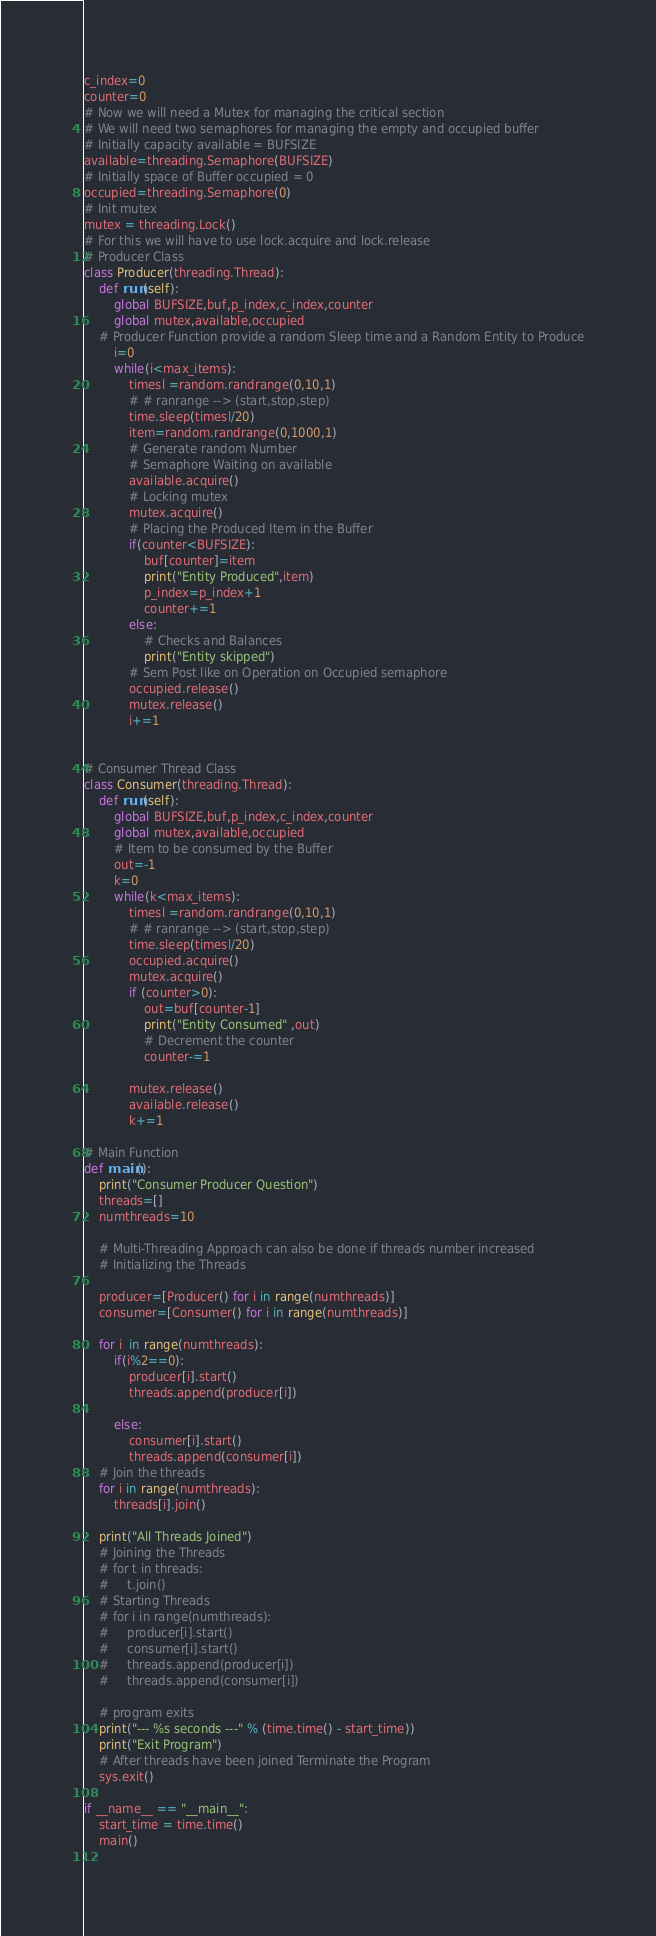<code> <loc_0><loc_0><loc_500><loc_500><_Python_>c_index=0
counter=0
# Now we will need a Mutex for managing the critical section
# We will need two semaphores for managing the empty and occupied buffer
# Initially capacity available = BUFSIZE
available=threading.Semaphore(BUFSIZE)
# Initially space of Buffer occupied = 0
occupied=threading.Semaphore(0)
# Init mutex 
mutex = threading.Lock()
# For this we will have to use lock.acquire and lock.release
# Producer Class 
class Producer(threading.Thread):
    def run(self):
        global BUFSIZE,buf,p_index,c_index,counter
        global mutex,available,occupied
    # Producer Function provide a random Sleep time and a Random Entity to Produce
        i=0
        while(i<max_items):
            timesl =random.randrange(0,10,1)
            # # ranrange --> (start,stop,step)
            time.sleep(timesl/20)
            item=random.randrange(0,1000,1)
            # Generate random Number
            # Semaphore Waiting on available 
            available.acquire()
            # Locking mutex
            mutex.acquire()
            # Placing the Produced Item in the Buffer 
            if(counter<BUFSIZE):
                buf[counter]=item
                print("Entity Produced",item)
                p_index=p_index+1
                counter+=1
            else:
                # Checks and Balances
                print("Entity skipped")
            # Sem Post like on Operation on Occupied semaphore
            occupied.release()
            mutex.release()
            i+=1


# Consumer Thread Class
class Consumer(threading.Thread):
    def run(self):
        global BUFSIZE,buf,p_index,c_index,counter
        global mutex,available,occupied
        # Item to be consumed by the Buffer
        out=-1
        k=0
        while(k<max_items):
            timesl =random.randrange(0,10,1)
            # # ranrange --> (start,stop,step)
            time.sleep(timesl/20)
            occupied.acquire()
            mutex.acquire()
            if (counter>0):
                out=buf[counter-1]
                print("Entity Consumed" ,out)
                # Decrement the counter
                counter-=1

            mutex.release()
            available.release()
            k+=1

# Main Function
def main():
    print("Consumer Producer Question")
    threads=[]
    numthreads=10
    
    # Multi-Threading Approach can also be done if threads number increased
    # Initializing the Threads

    producer=[Producer() for i in range(numthreads)]
    consumer=[Consumer() for i in range(numthreads)]

    for i  in range(numthreads):
        if(i%2==0):
            producer[i].start()
            threads.append(producer[i])
           
        else:
            consumer[i].start()
            threads.append(consumer[i])
    # Join the threads
    for i in range(numthreads):
        threads[i].join()

    print("All Threads Joined")
    # Joining the Threads
    # for t in threads:
    #     t.join()
    # Starting Threads
    # for i in range(numthreads):
    #     producer[i].start()
    #     consumer[i].start()
    #     threads.append(producer[i])
    #     threads.append(consumer[i])
   
    # program exits
    print("--- %s seconds ---" % (time.time() - start_time))
    print("Exit Program")
    # After threads have been joined Terminate the Program
    sys.exit()

if __name__ == "__main__":
    start_time = time.time()
    main()
    




</code> 